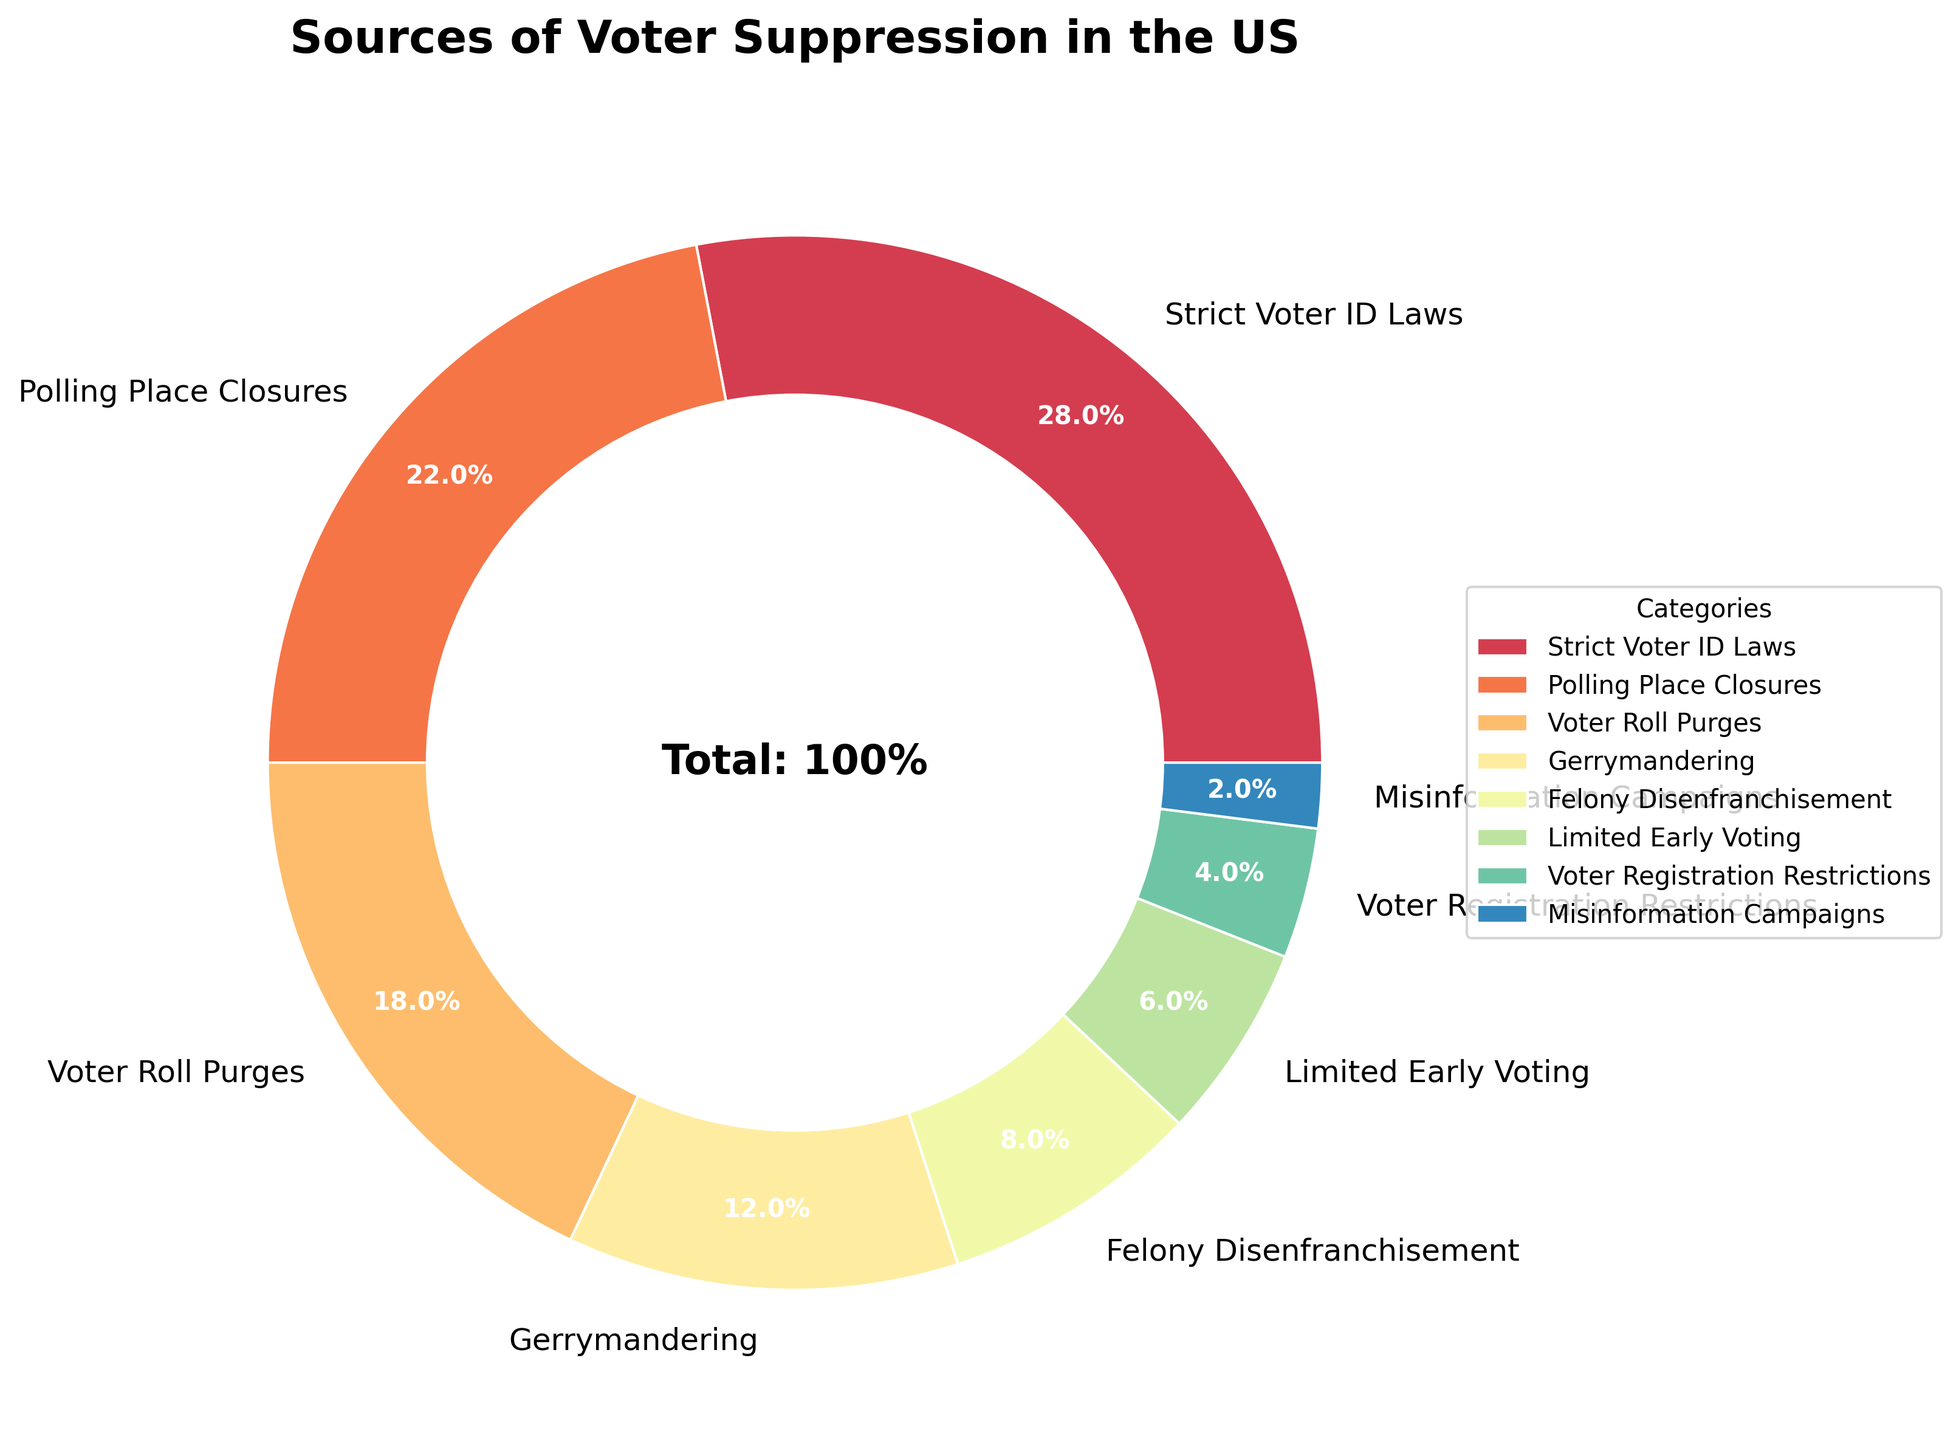Which category accounts for the highest percentage of voter suppression? The segment labeled "Strict Voter ID Laws" is the largest in the pie chart, and the percentage next to it indicates 28%, which is the highest among all categories.
Answer: Strict Voter ID Laws What is the combined percentage of Polling Place Closures and Voter Roll Purges? From the figure, Polling Place Closures is 22% and Voter Roll Purges is 18%. Adding these two percentages together: 22% + 18% = 40%.
Answer: 40% Which category has a lesser percentage of voter suppression, Limited Early Voting or Misinformation Campaigns? Referring to the figure, Limited Early Voting is 6% and Misinformation Campaigns is 2%. Since 6% is greater than 2%, Misinformation Campaigns has a lesser percentage.
Answer: Misinformation Campaigns Is Gerrymandering a more significant source of voter suppression than Felony Disenfranchisement? The pie chart shows Gerrymandering at 12% and Felony Disenfranchisement at 8%. Comparing these values, 12% is greater than 8%, indicating that Gerrymandering is a more significant source.
Answer: Yes What is the average percentage of the three largest categories? The three largest categories are Strict Voter ID Laws (28%), Polling Place Closures (22%), and Voter Roll Purges (18%). The average is calculated as (28 + 22 + 18) / 3 = 68 / 3 = approximately 22.67%.
Answer: 22.67% Identify the categories that account for less than 10% of voter suppression each. The pie chart shows that Felony Disenfranchisement (8%), Limited Early Voting (6%), Voter Registration Restrictions (4%), and Misinformation Campaigns (2%) each account for less than 10%.
Answer: Felony Disenfranchisement, Limited Early Voting, Voter Registration Restrictions, Misinformation Campaigns 